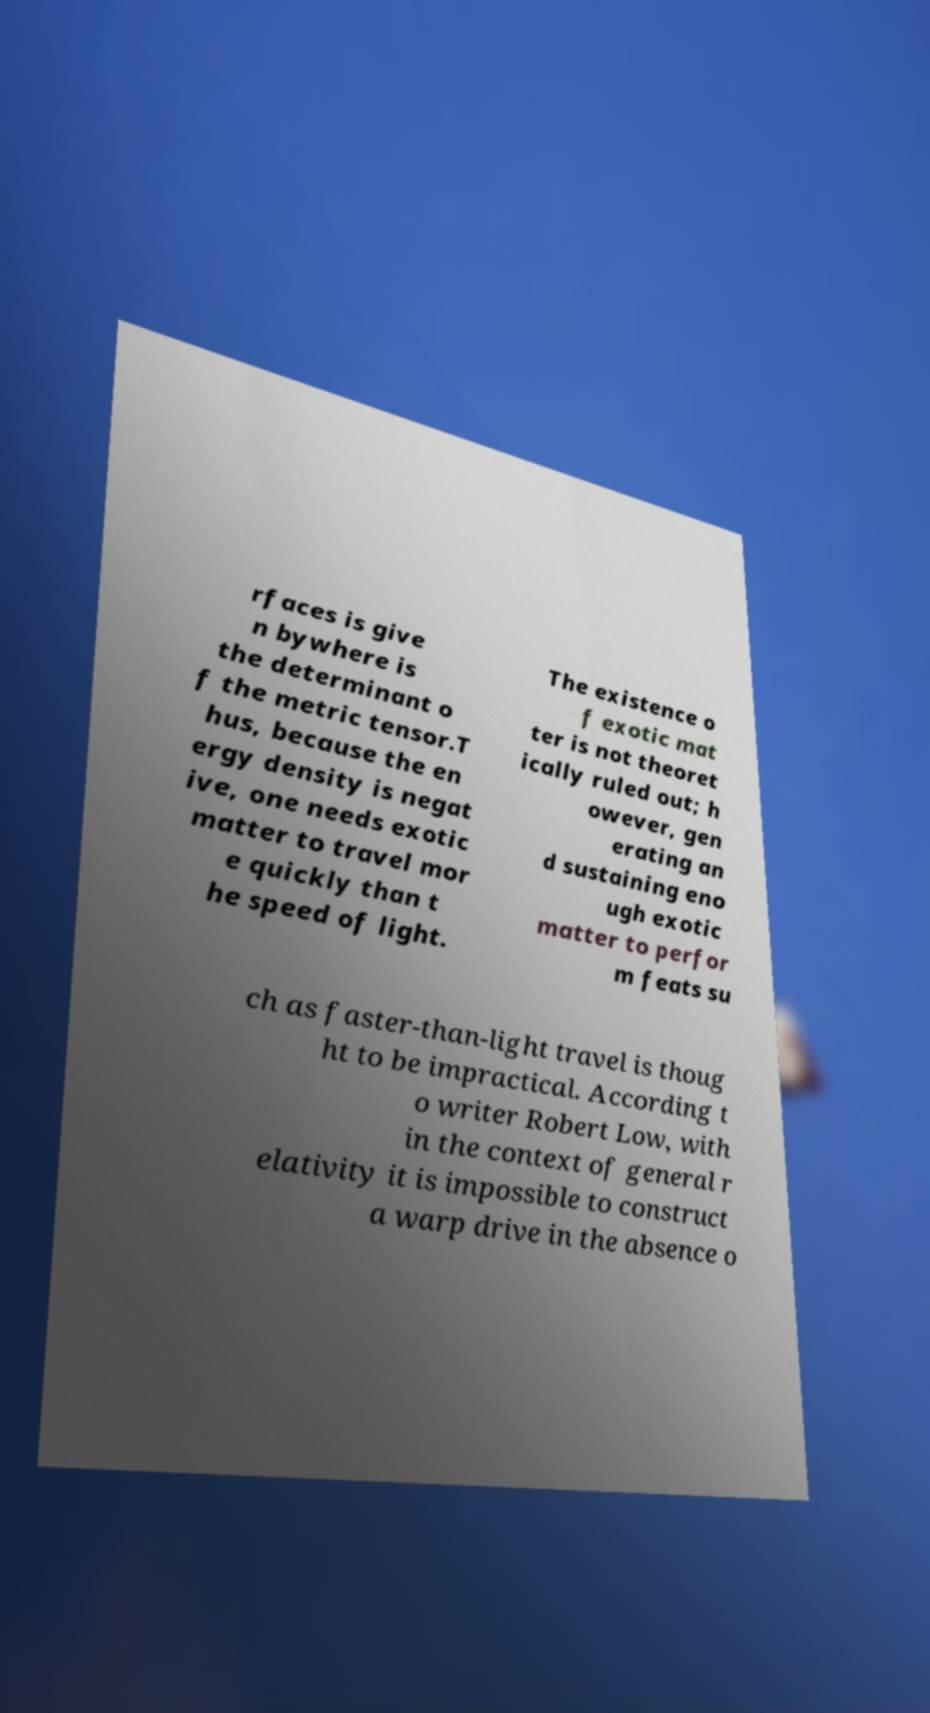Could you extract and type out the text from this image? rfaces is give n bywhere is the determinant o f the metric tensor.T hus, because the en ergy density is negat ive, one needs exotic matter to travel mor e quickly than t he speed of light. The existence o f exotic mat ter is not theoret ically ruled out; h owever, gen erating an d sustaining eno ugh exotic matter to perfor m feats su ch as faster-than-light travel is thoug ht to be impractical. According t o writer Robert Low, with in the context of general r elativity it is impossible to construct a warp drive in the absence o 